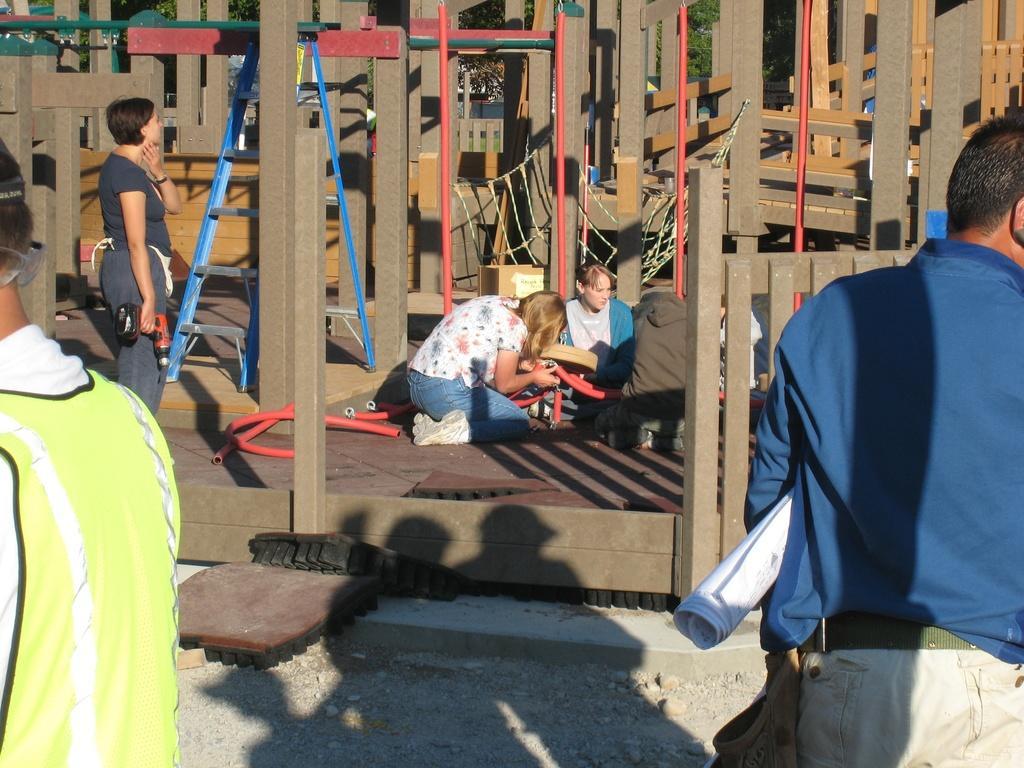How would you summarize this image in a sentence or two? In the image we can see there are people sanding and some of them are sitting, they are wearing clothes and some of them are wearing shoes and carrying objects in hands. Here we can see the stones and the construction. 